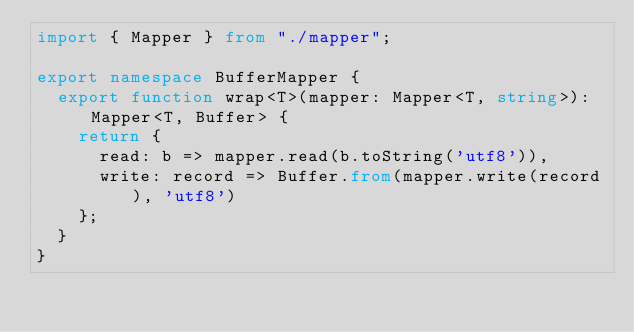Convert code to text. <code><loc_0><loc_0><loc_500><loc_500><_TypeScript_>import { Mapper } from "./mapper";

export namespace BufferMapper {
  export function wrap<T>(mapper: Mapper<T, string>): Mapper<T, Buffer> {
    return {
      read: b => mapper.read(b.toString('utf8')),
      write: record => Buffer.from(mapper.write(record), 'utf8')
    };
  }
}
</code> 